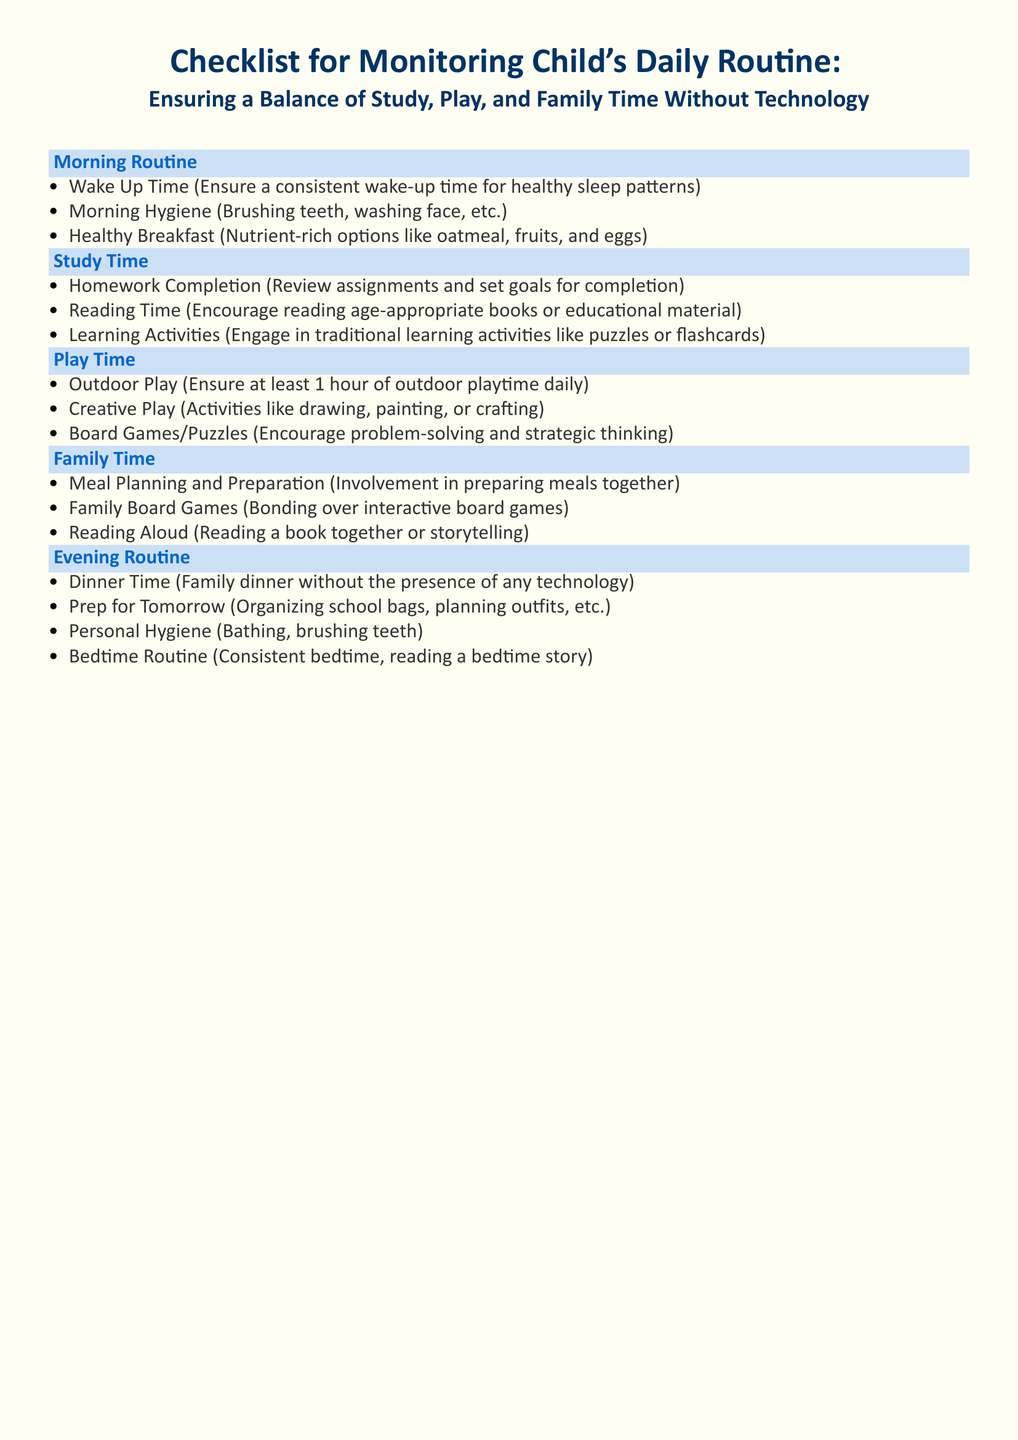What is the first item listed in the Morning Routine? The first item listed in the Morning Routine section is "Wake Up Time," which is about ensuring a consistent wake-up time for healthy sleep patterns.
Answer: Wake Up Time How many items are in the Family Time section? The Family Time section contains a total of four items that involve various family bonding activities.
Answer: 4 What activity is suggested for Quiet Study Environment? The document emphasizes creating a Quiet Study Environment where distractions are minimized to enhance focus and learning.
Answer: distraction-free, quiet space What type of breakfast is encouraged? The checklist suggests a Healthy Breakfast focusing on options that are rich in nutrients for better energy and concentration.
Answer: Nutrient-rich options How long should Outdoor Play last daily? The document recommends ensuring at least one hour of outdoor playtime as part of a balanced daily routine for the child.
Answer: 1 hour What does the Evening Routine emphasize during dinner? The Evening Routine highlights having Dinner Time as a family activity without the presence of any technology, promoting better interaction.
Answer: family dinner without technology What type of play is suggested under Creative Play? The checklist includes activities like drawing, painting, or crafting as suggested under the Creative Play category, encouraging artistic expression.
Answer: drawing, painting, or crafting Which activity is recommended for preparation for the next day? The Evening Routine mentions "Prep for Tomorrow," encompassing organizing school bags, planning outfits, and preparing necessary items for school.
Answer: Organizing school bags, planning outfits What is listed as a morning health practice? In the morning routine, "Morning Hygiene" is mentioned, which involves basic cleanliness activities essential for starting the day.
Answer: Brushing teeth, washing face 